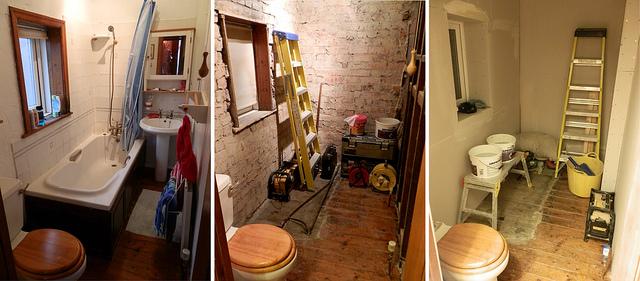Is the bathroom being remodeled?
Give a very brief answer. Yes. How many white buckets are there?
Write a very short answer. 3. Is there a toilet in each picture?
Write a very short answer. Yes. 